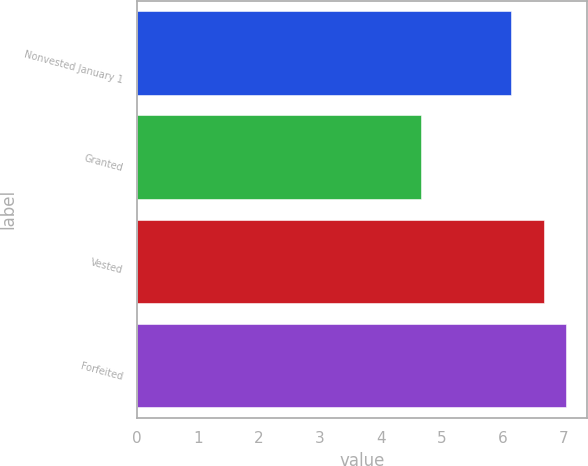Convert chart to OTSL. <chart><loc_0><loc_0><loc_500><loc_500><bar_chart><fcel>Nonvested January 1<fcel>Granted<fcel>Vested<fcel>Forfeited<nl><fcel>6.14<fcel>4.66<fcel>6.68<fcel>7.03<nl></chart> 